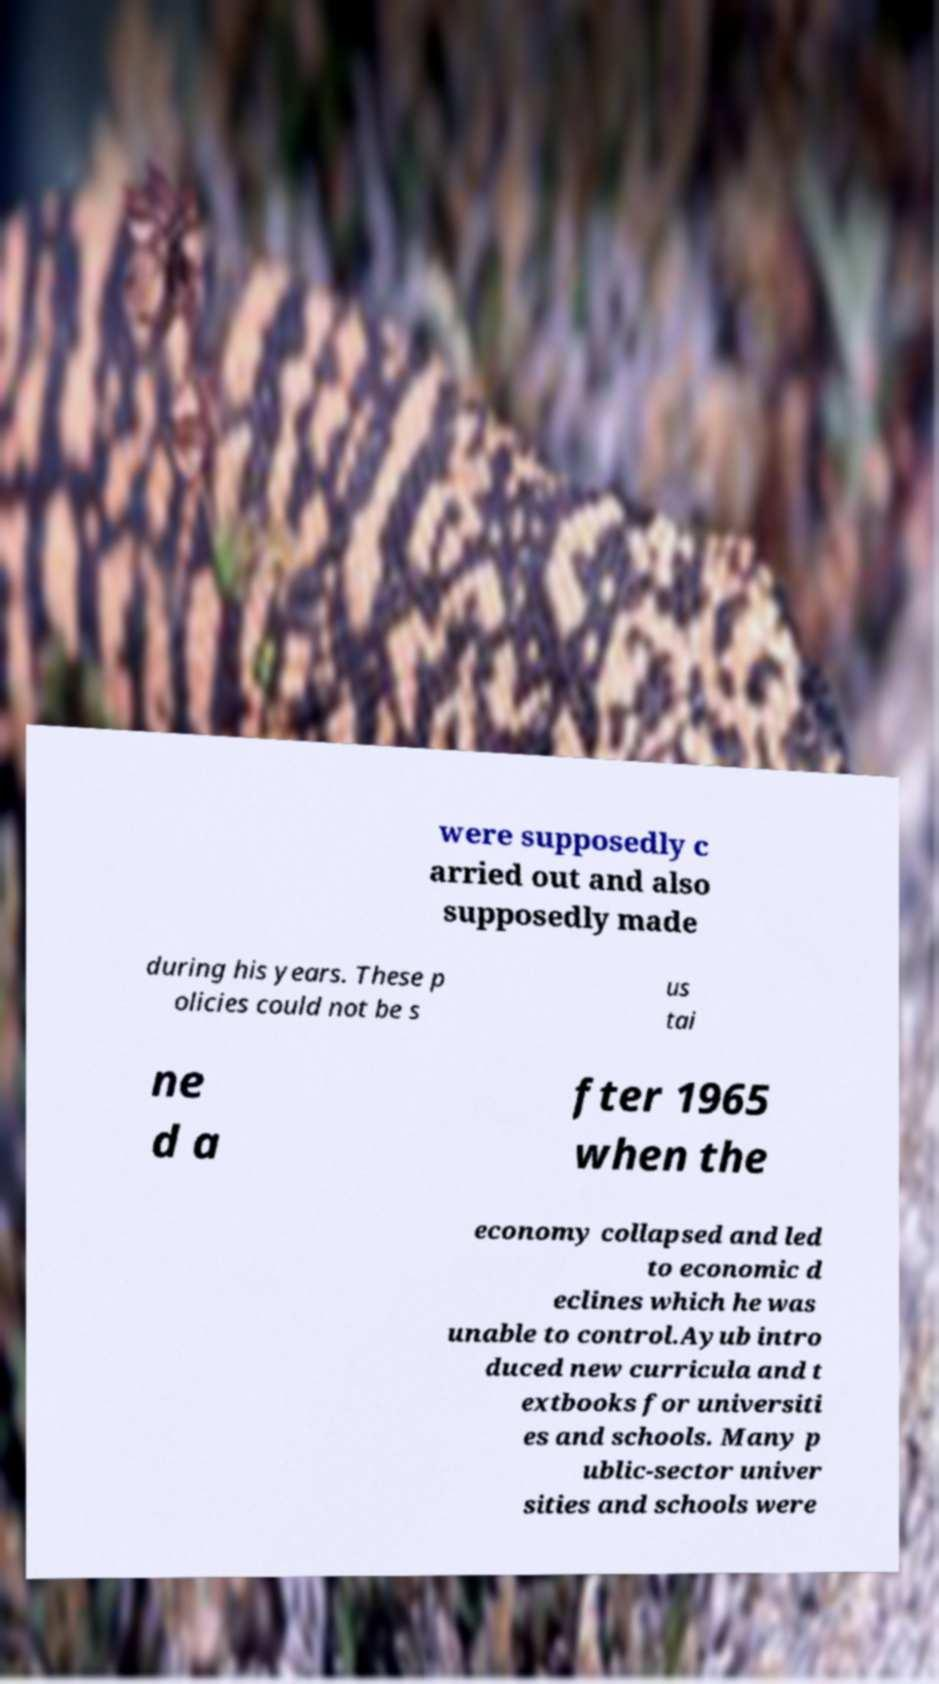Could you assist in decoding the text presented in this image and type it out clearly? were supposedly c arried out and also supposedly made during his years. These p olicies could not be s us tai ne d a fter 1965 when the economy collapsed and led to economic d eclines which he was unable to control.Ayub intro duced new curricula and t extbooks for universiti es and schools. Many p ublic-sector univer sities and schools were 